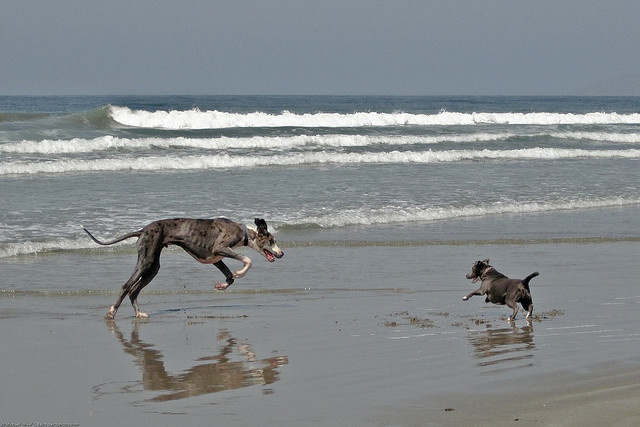Describe the objects in this image and their specific colors. I can see dog in gray and black tones and dog in gray and black tones in this image. 